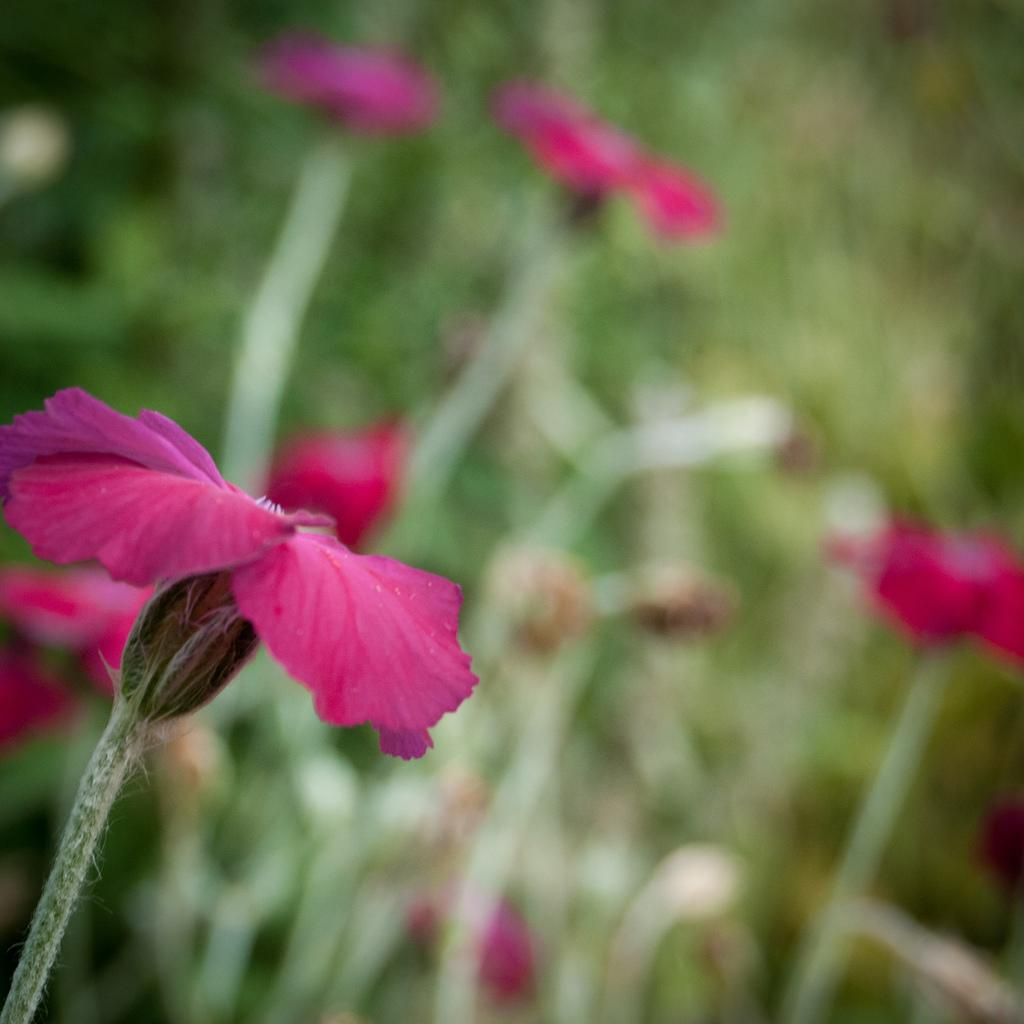What is present in the image? There are flowers in the image. Can you describe the background of the image? The background of the image is blurry. What type of tin can be seen in the image? There is no tin present in the image; it features flowers and a blurry background. Is there any snow visible in the image? There is no snow present in the image; it features flowers and a blurry background. 